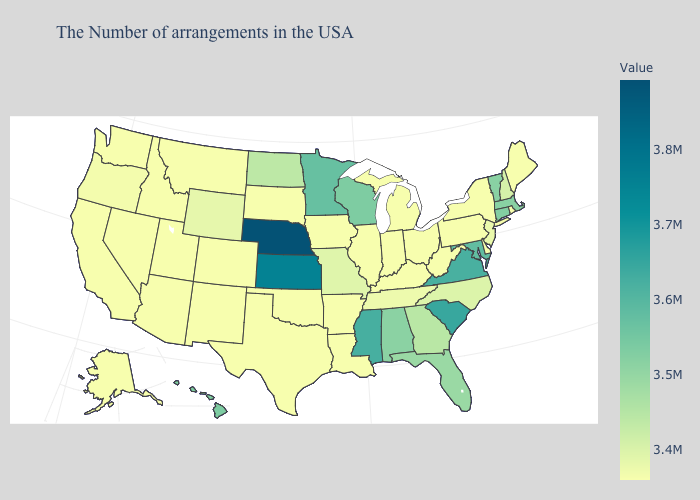Is the legend a continuous bar?
Be succinct. Yes. Among the states that border West Virginia , does Virginia have the highest value?
Quick response, please. Yes. Does Arkansas have a higher value than Georgia?
Give a very brief answer. No. Among the states that border South Carolina , does Georgia have the highest value?
Keep it brief. Yes. Which states have the lowest value in the West?
Be succinct. Colorado, New Mexico, Utah, Montana, Arizona, Idaho, Nevada, California, Washington, Alaska. Does North Carolina have the lowest value in the South?
Answer briefly. No. Does Kentucky have a higher value than North Dakota?
Short answer required. No. Which states hav the highest value in the West?
Quick response, please. Hawaii. 